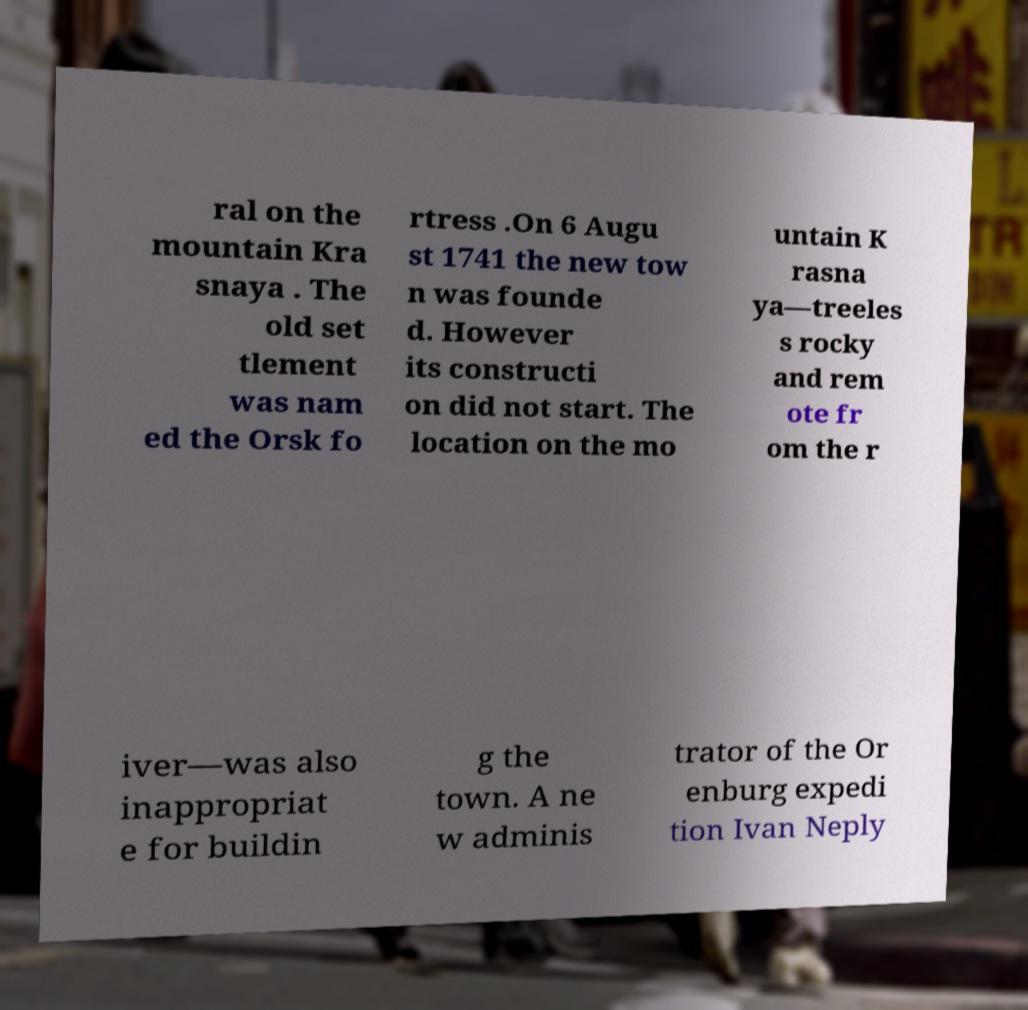Can you accurately transcribe the text from the provided image for me? ral on the mountain Kra snaya . The old set tlement was nam ed the Orsk fo rtress .On 6 Augu st 1741 the new tow n was founde d. However its constructi on did not start. The location on the mo untain K rasna ya—treeles s rocky and rem ote fr om the r iver—was also inappropriat e for buildin g the town. A ne w adminis trator of the Or enburg expedi tion Ivan Neply 